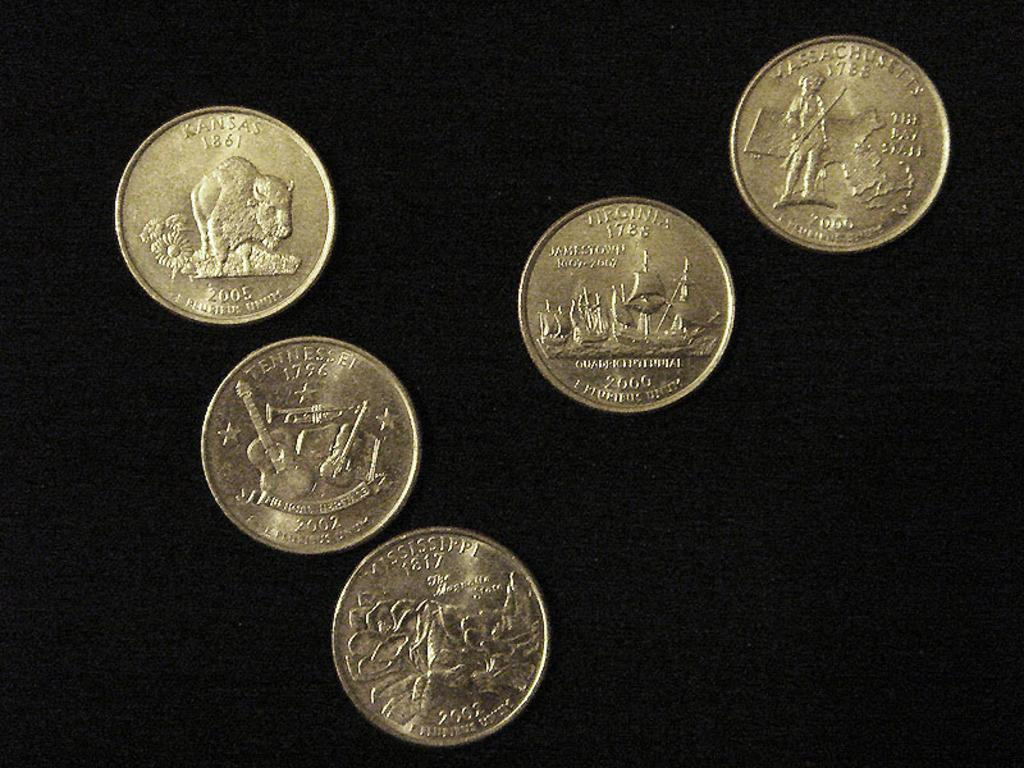Provide a one-sentence caption for the provided image. Various US quarters from states like Virginia and Kansas. 